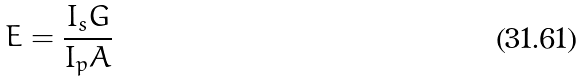<formula> <loc_0><loc_0><loc_500><loc_500>E = \frac { I _ { s } G } { I _ { p } A }</formula> 